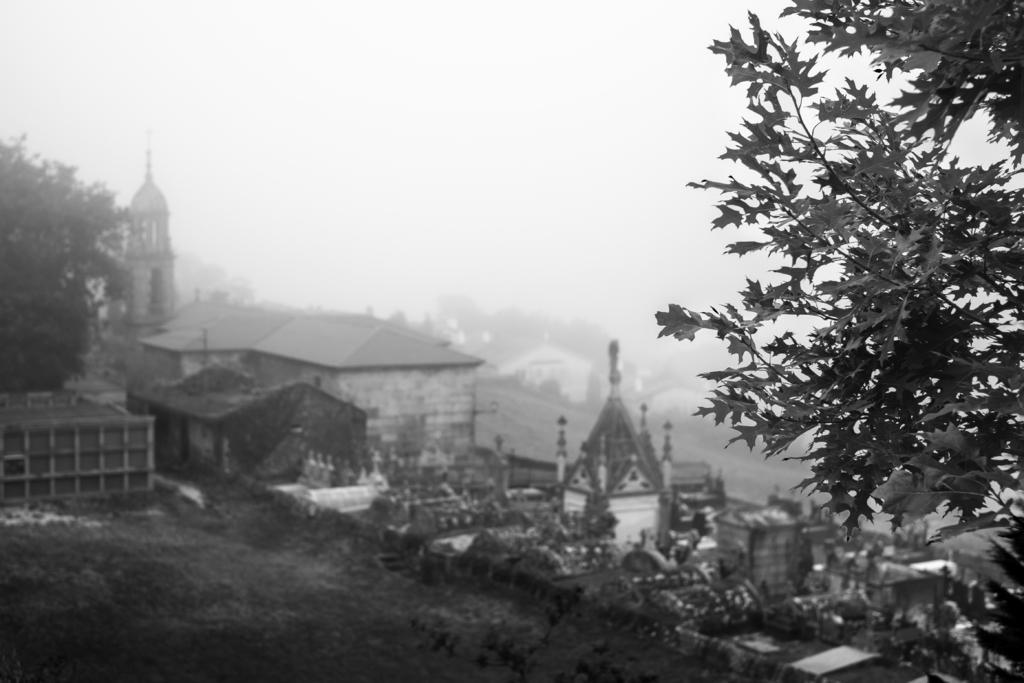Can you describe this image briefly? In this image there is the sky towards the top of the image, there are buildings, there is a tree towards the right of the image, there is a tree towards the left of the image, there is grass towards the bottom of the image. 